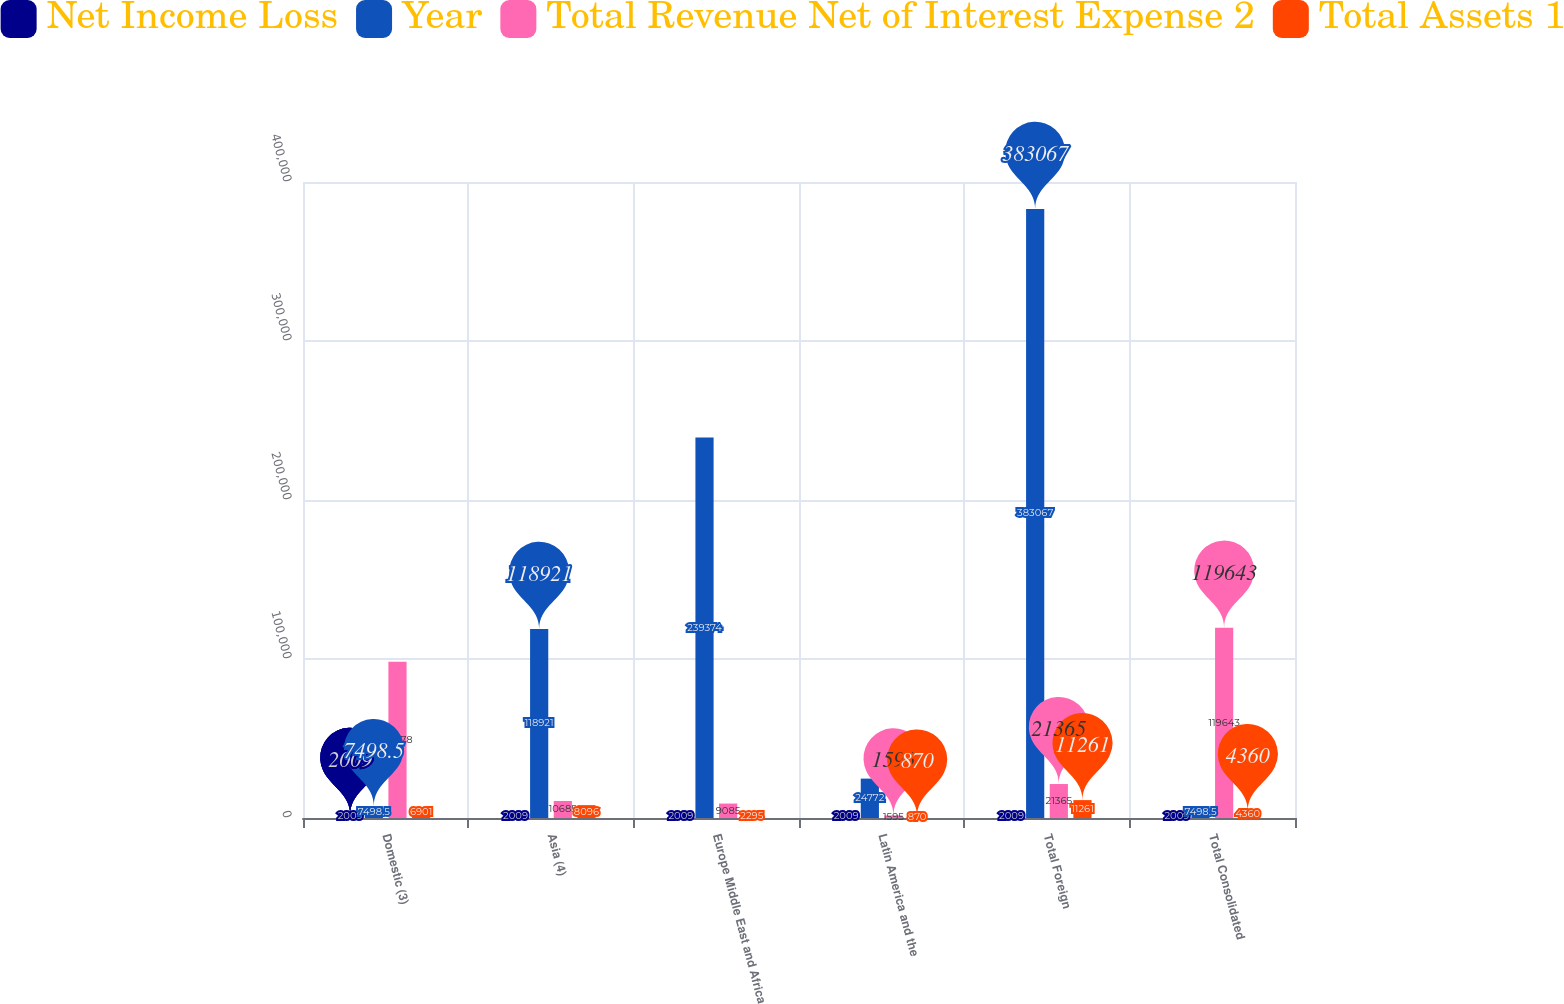<chart> <loc_0><loc_0><loc_500><loc_500><stacked_bar_chart><ecel><fcel>Domestic (3)<fcel>Asia (4)<fcel>Europe Middle East and Africa<fcel>Latin America and the<fcel>Total Foreign<fcel>Total Consolidated<nl><fcel>Net Income Loss<fcel>2009<fcel>2009<fcel>2009<fcel>2009<fcel>2009<fcel>2009<nl><fcel>Year<fcel>7498.5<fcel>118921<fcel>239374<fcel>24772<fcel>383067<fcel>7498.5<nl><fcel>Total Revenue Net of Interest Expense 2<fcel>98278<fcel>10685<fcel>9085<fcel>1595<fcel>21365<fcel>119643<nl><fcel>Total Assets 1<fcel>6901<fcel>8096<fcel>2295<fcel>870<fcel>11261<fcel>4360<nl></chart> 